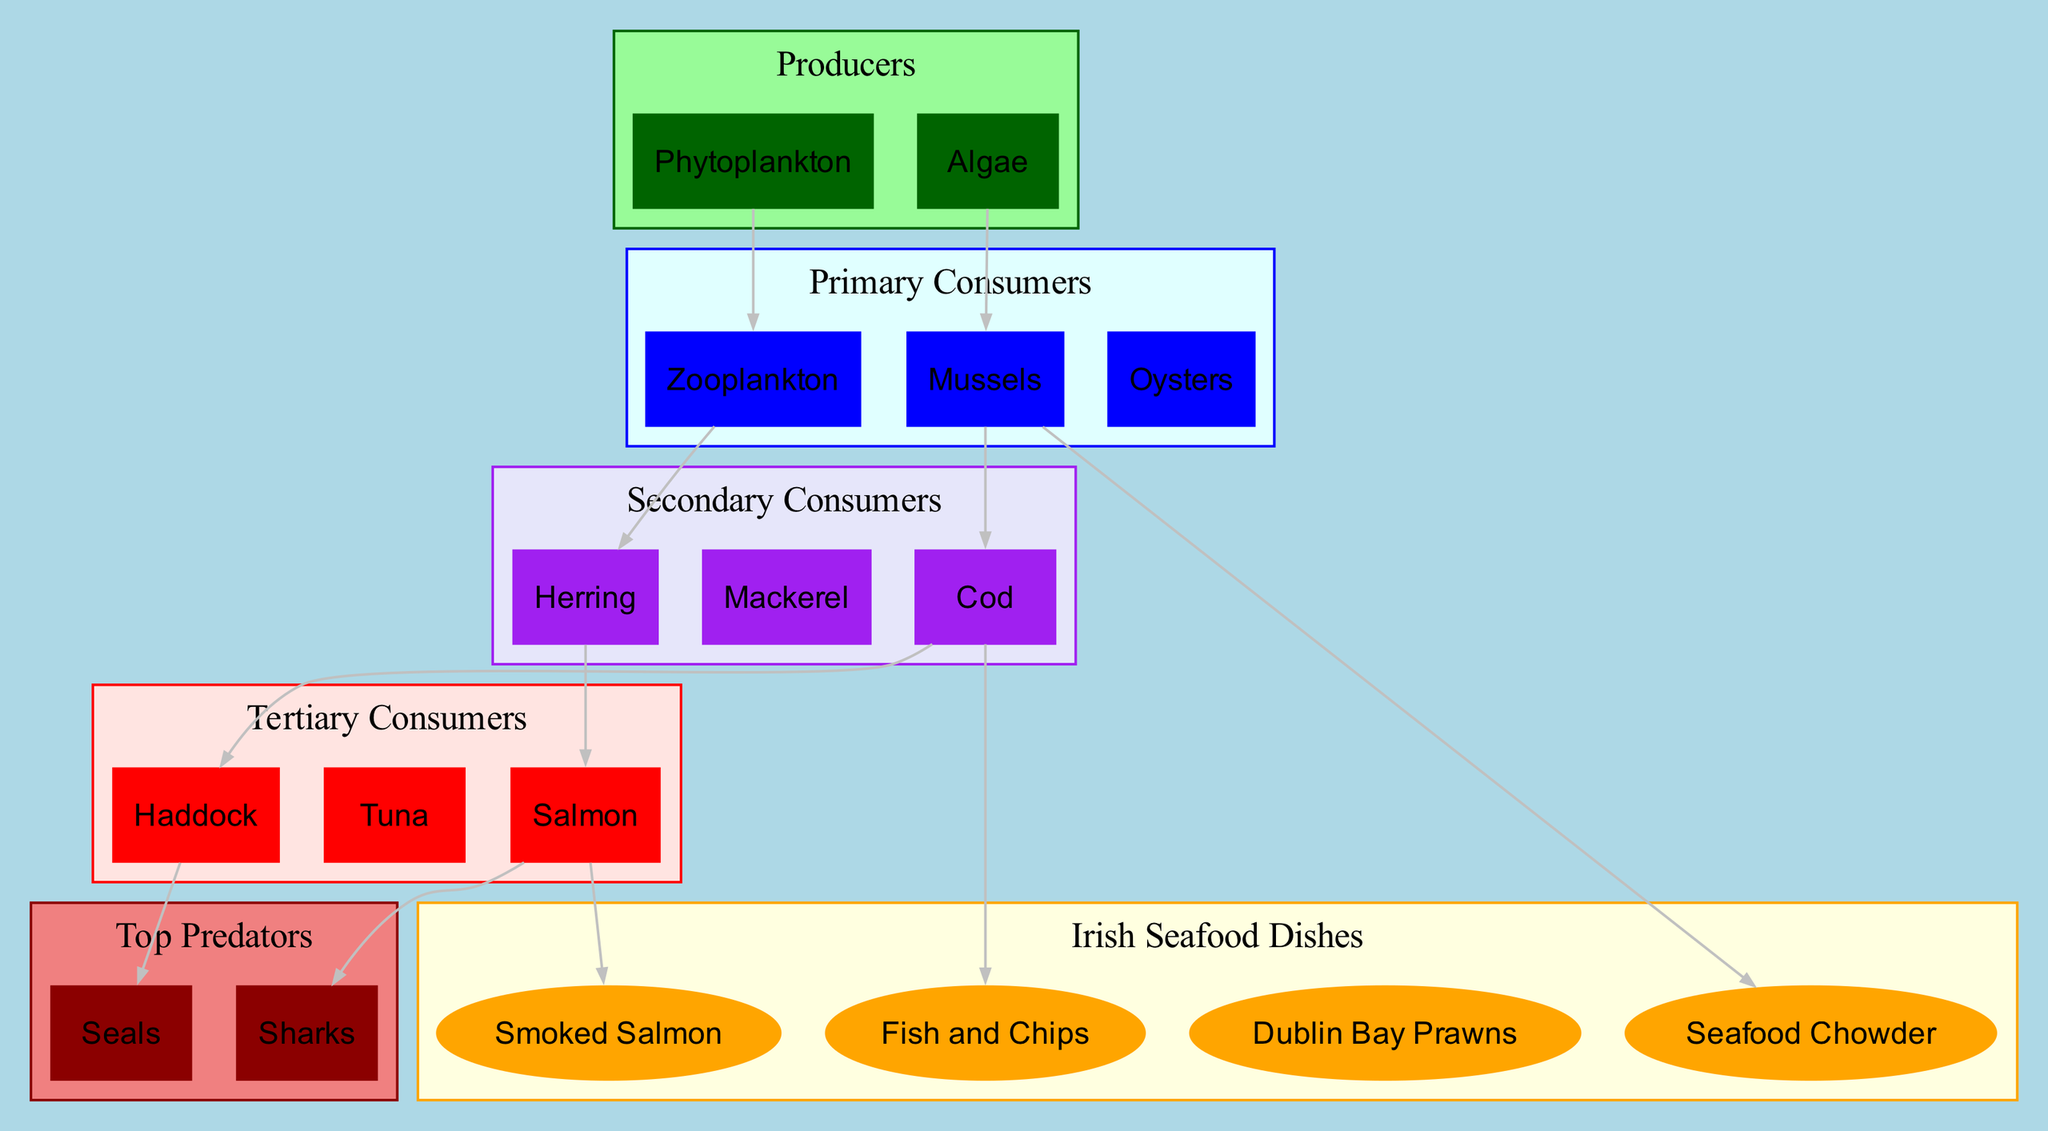What are the producers in the Atlantic Ocean's food chain? The diagram indicates that the producers in the Atlantic Ocean's food chain are listed under the Producers cluster. Those are Phytoplankton and Algae.
Answer: Phytoplankton, Algae Which primary consumer is connected to mussels? The diagram shows a connection indicated by an arrow from Mussels to Cod in the Primary Consumers cluster. This means that mussels are considered a primary consumer linked to a secondary consumer.
Answer: Cod How many tertiary consumers are there? Looking at the Tertiary Consumers cluster, we can count the nodes, which list Salmon, Tuna, and Haddock. This gives us a total of 3 tertiary consumers.
Answer: 3 Which dish is made from salmon? The diagram identifies a connection from Salmon to Smoked Salmon in the Irish Seafood Dishes cluster. This indicates that Smoked Salmon is a dish made from salmon.
Answer: Smoked Salmon What is the last consumer in the food chain before reaching the top predators? The diagram indicates that the last consumer before the top predators is Salmon, which is linked to Sharks. Therefore, Salmon is the final step before reaching top predators.
Answer: Salmon Which animal is a top predator linked to haddock? Following the arrows in the diagram, Haddock is connected to Seals, which means that Seals are a top predator linked to haddock in the food chain.
Answer: Seals How many connections involve mussels? By analyzing the connections in the diagram that involve mussels, we find that Mussels are connected to Cod and Seafood Chowder, leading to a total of 2 connections involving mussels.
Answer: 2 What is the connection between zooplankton and herring? The diagram states a direct connection from Zooplankton to Herring, indicating that Zooplankton serves as a food source for Herring.
Answer: Zooplankton → Herring 